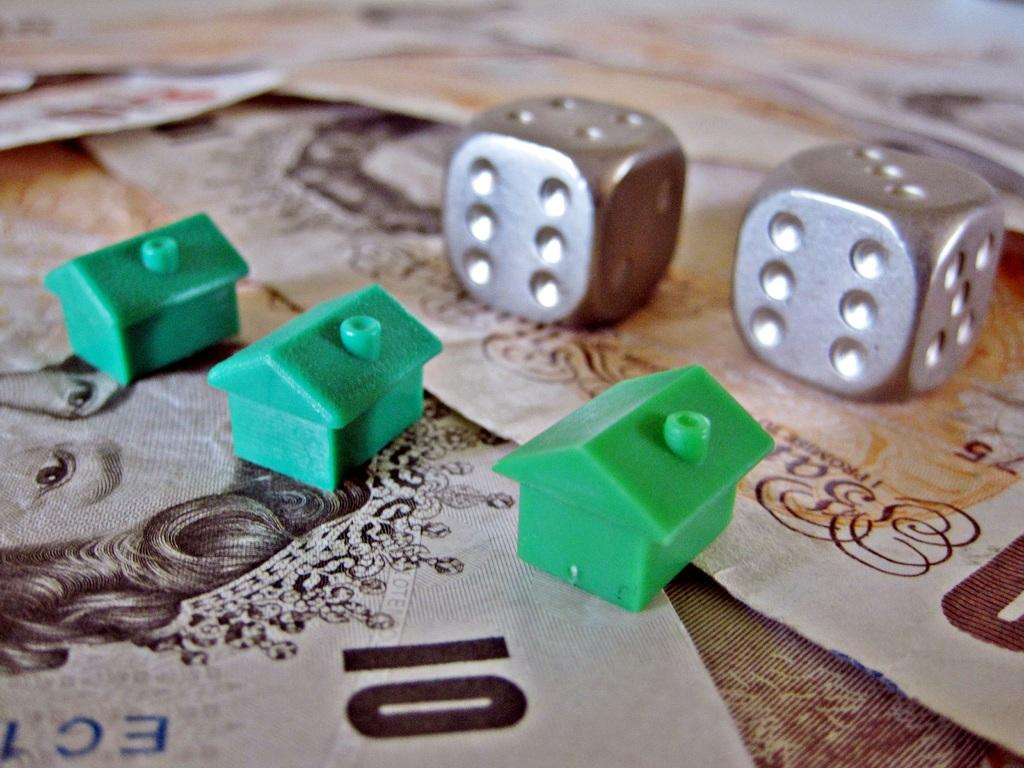What objects are present on the posters in the image? There are two dices and small toy houses on the posters in the image. What type of objects are the dices and toy houses? The dices are gaming objects, and the toy houses are miniature models of houses. Where are the dices and toy houses located in the image? The dices and toy houses are on posters in the center of the image. How does the fear of the boat affect the transport in the image? There is no boat or fear present in the image, so this question cannot be answered. 